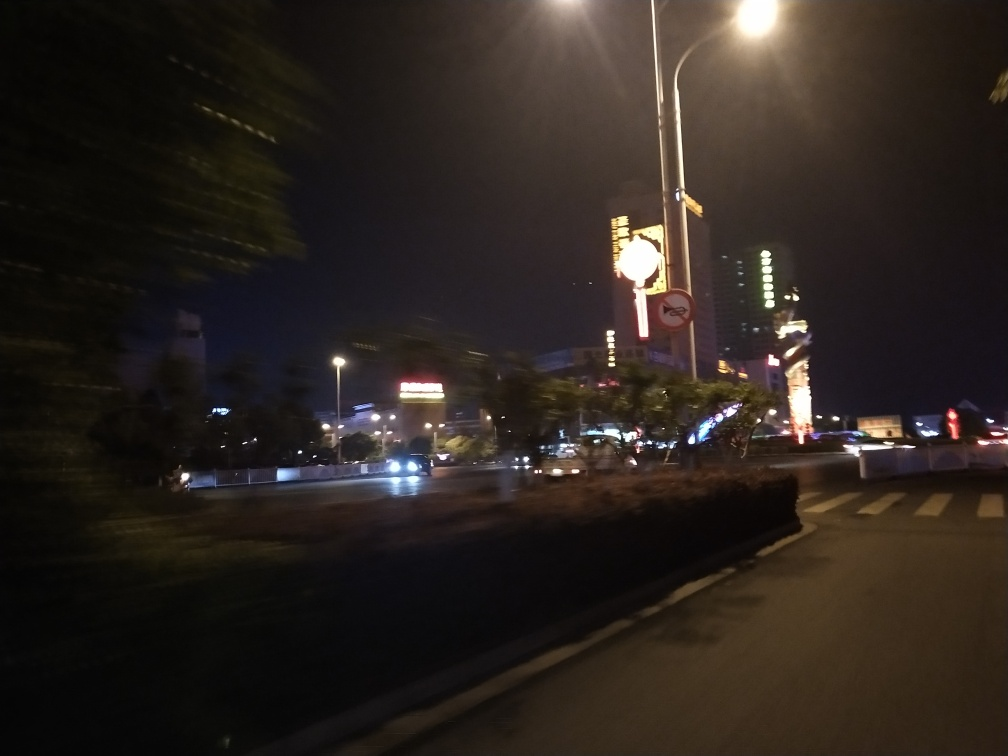Is the street blurry? Yes, the street appears blurry. This is likely due to motion blur, a common occurrence in photography when the camera moves during a long exposure, or when objects within the frame are moving quickly, such as moving vehicles. 